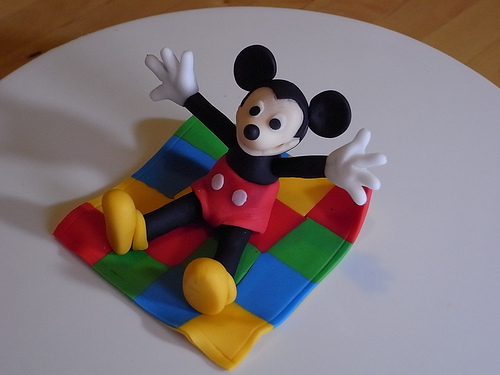<image>
Can you confirm if the mickey is next to the table? No. The mickey is not positioned next to the table. They are located in different areas of the scene. Is there a mouse on the pad? Yes. Looking at the image, I can see the mouse is positioned on top of the pad, with the pad providing support. Is there a mickey mouse on the floor? No. The mickey mouse is not positioned on the floor. They may be near each other, but the mickey mouse is not supported by or resting on top of the floor. 